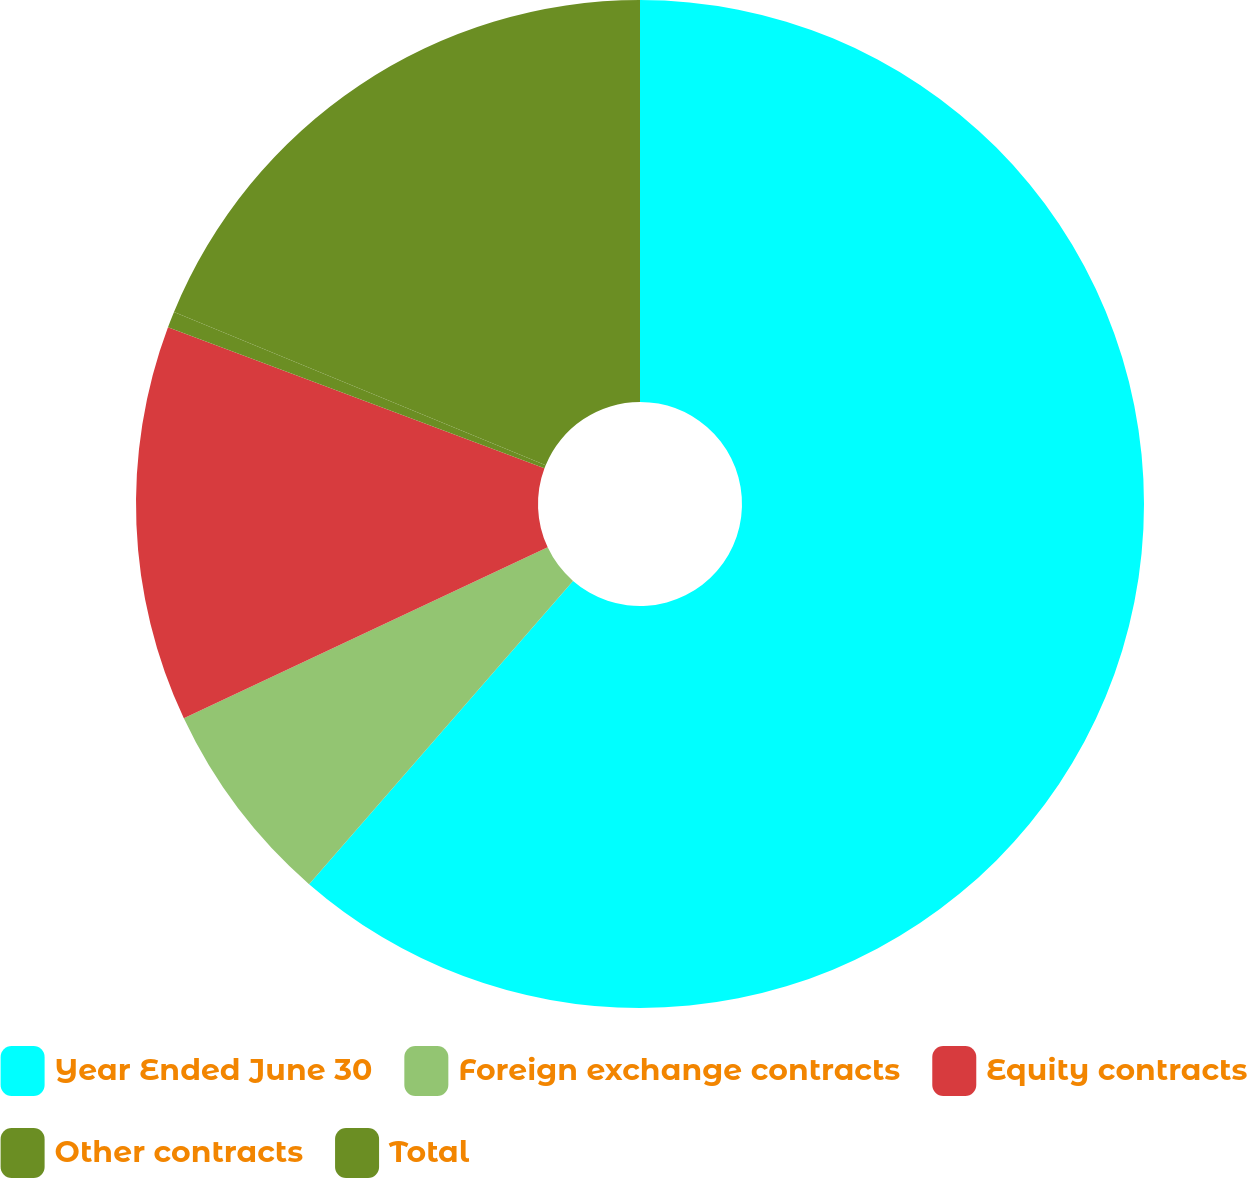<chart> <loc_0><loc_0><loc_500><loc_500><pie_chart><fcel>Year Ended June 30<fcel>Foreign exchange contracts<fcel>Equity contracts<fcel>Other contracts<fcel>Total<nl><fcel>61.4%<fcel>6.61%<fcel>12.69%<fcel>0.52%<fcel>18.78%<nl></chart> 